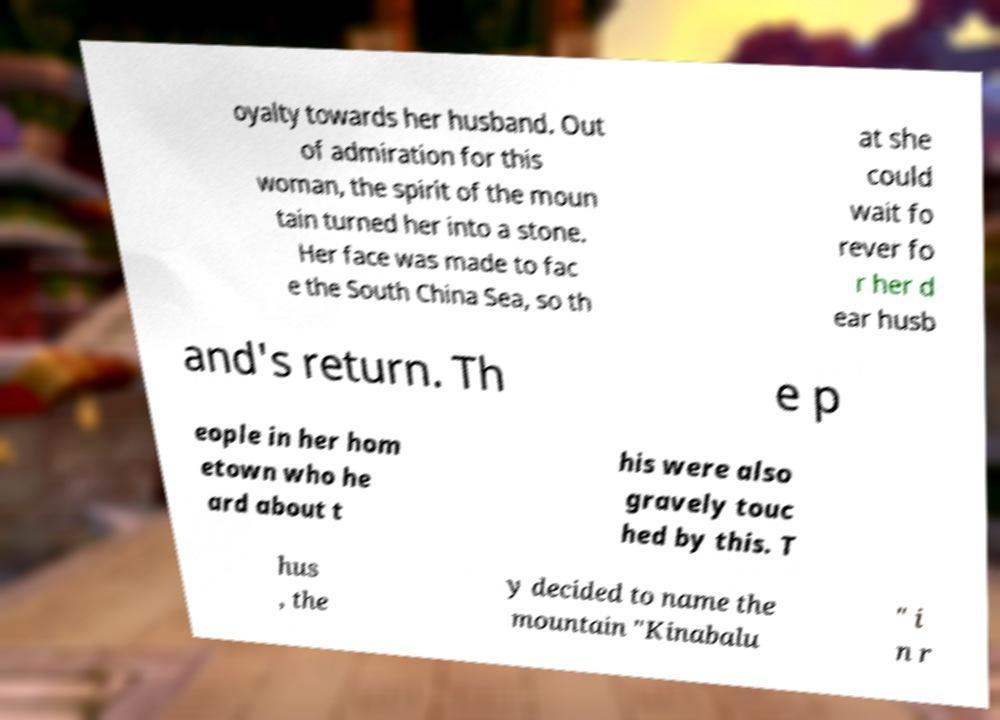Please read and relay the text visible in this image. What does it say? oyalty towards her husband. Out of admiration for this woman, the spirit of the moun tain turned her into a stone. Her face was made to fac e the South China Sea, so th at she could wait fo rever fo r her d ear husb and's return. Th e p eople in her hom etown who he ard about t his were also gravely touc hed by this. T hus , the y decided to name the mountain "Kinabalu " i n r 